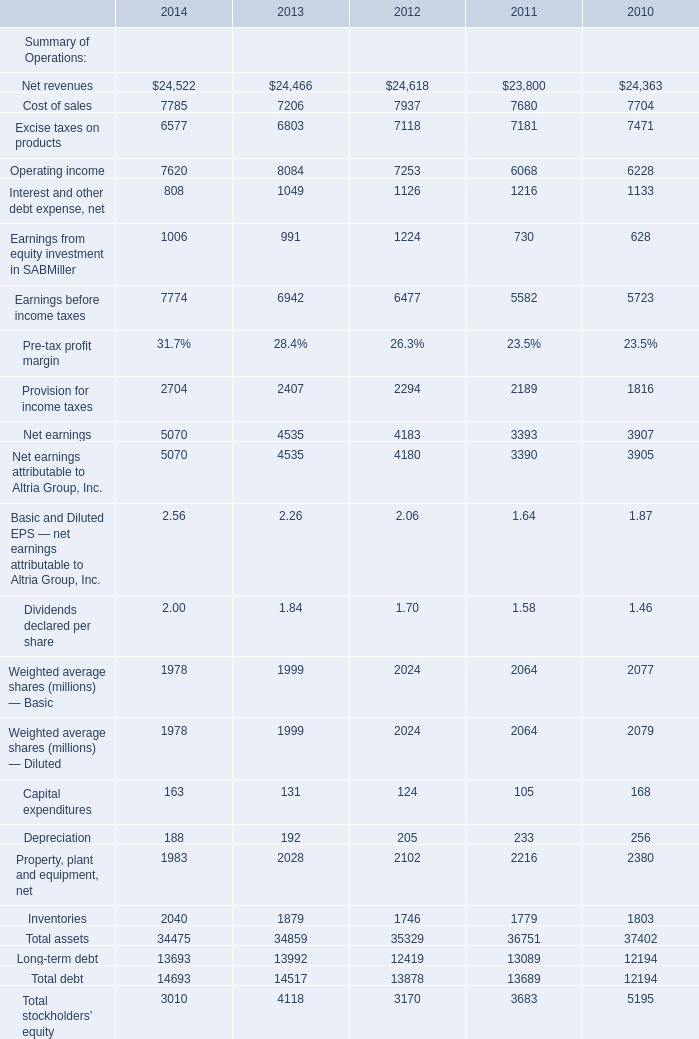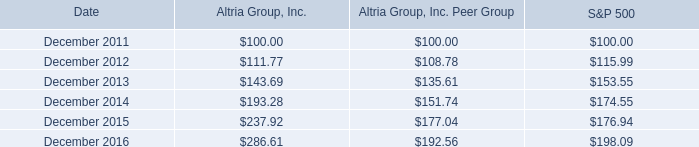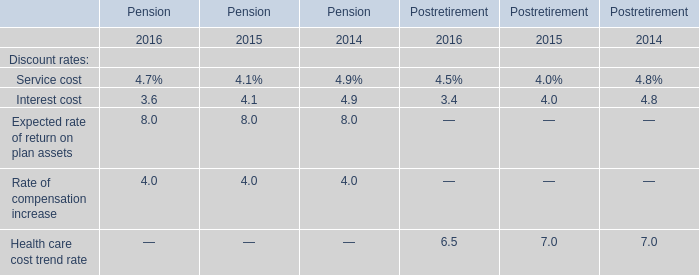What's the total amount of the Discount rates in the years where Basic and Diluted EPS — net earnings attributable to Altria Group, Inc. is greater than 2.5? 
Computations: (4.9 + 4.9)
Answer: 9.8. 